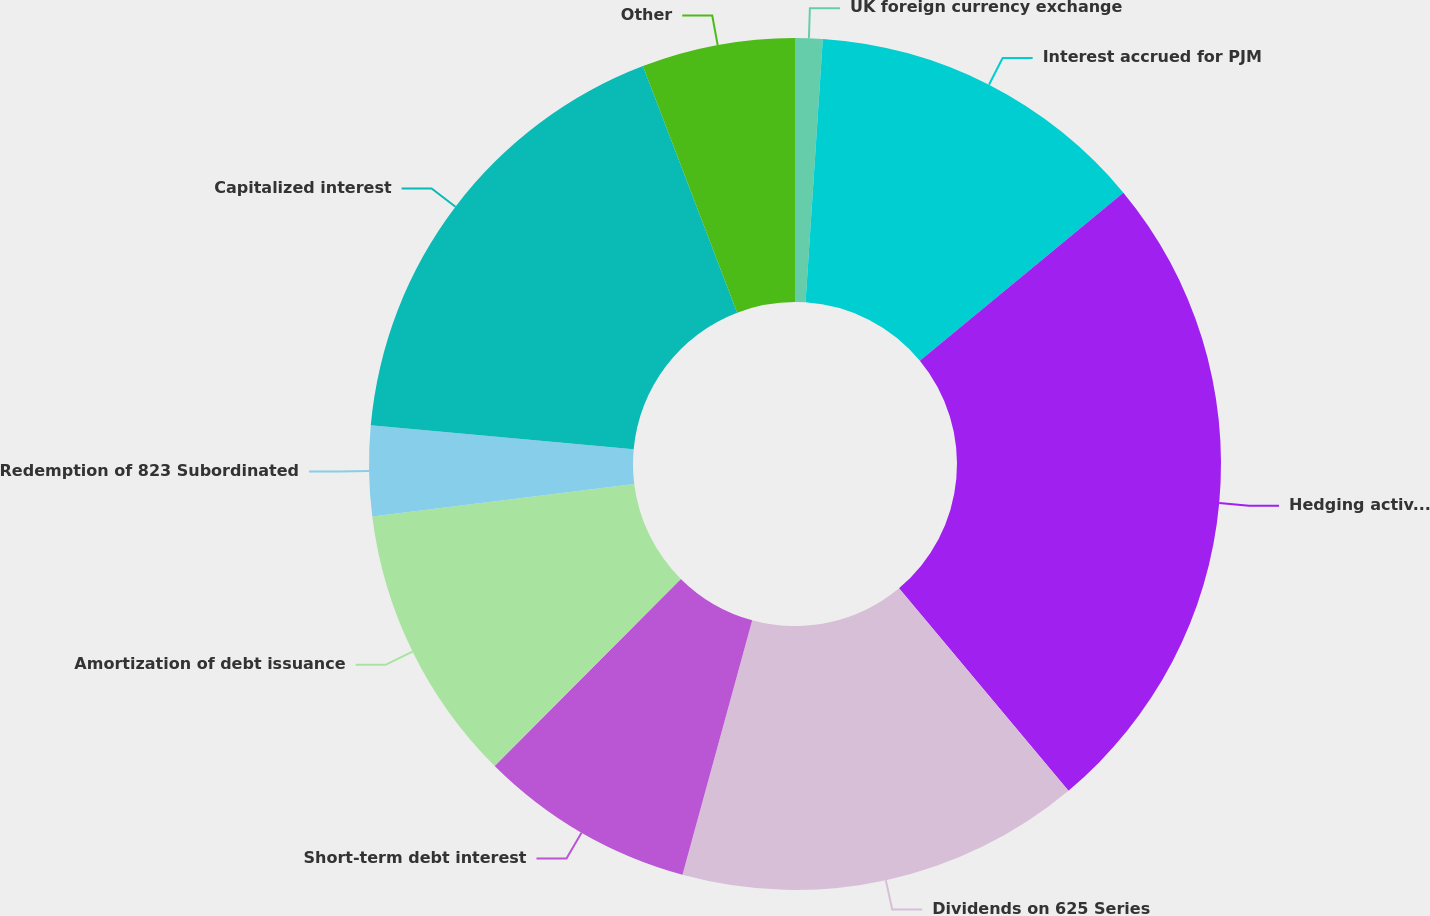Convert chart to OTSL. <chart><loc_0><loc_0><loc_500><loc_500><pie_chart><fcel>UK foreign currency exchange<fcel>Interest accrued for PJM<fcel>Hedging activities<fcel>Dividends on 625 Series<fcel>Short-term debt interest<fcel>Amortization of debt issuance<fcel>Redemption of 823 Subordinated<fcel>Capitalized interest<fcel>Other<nl><fcel>1.04%<fcel>12.97%<fcel>24.9%<fcel>15.35%<fcel>8.2%<fcel>10.58%<fcel>3.42%<fcel>17.74%<fcel>5.81%<nl></chart> 